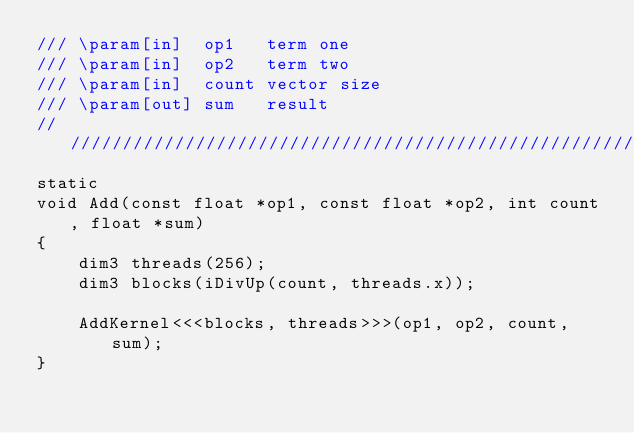<code> <loc_0><loc_0><loc_500><loc_500><_Cuda_>/// \param[in]  op1   term one
/// \param[in]  op2   term two
/// \param[in]  count vector size
/// \param[out] sum   result
///////////////////////////////////////////////////////////////////////////////
static
void Add(const float *op1, const float *op2, int count, float *sum)
{
    dim3 threads(256);
    dim3 blocks(iDivUp(count, threads.x));

    AddKernel<<<blocks, threads>>>(op1, op2, count, sum);
}
</code> 